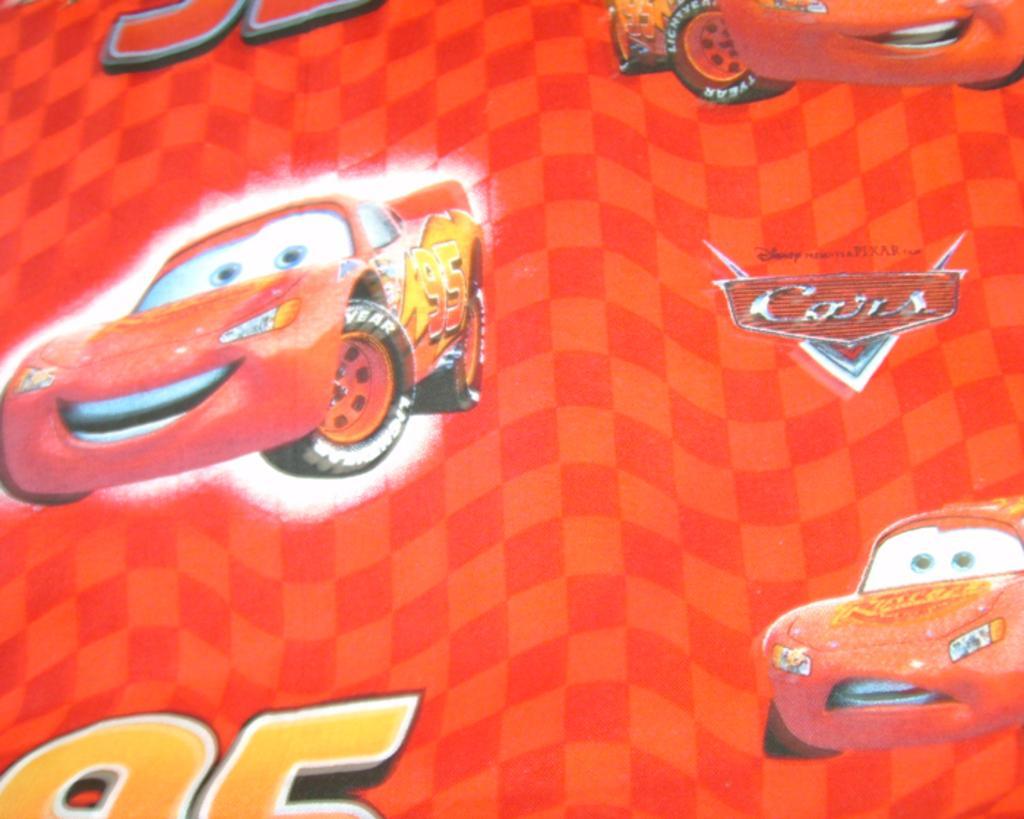Could you give a brief overview of what you see in this image? In this picture, we can see a poster with some text, and images on it. 